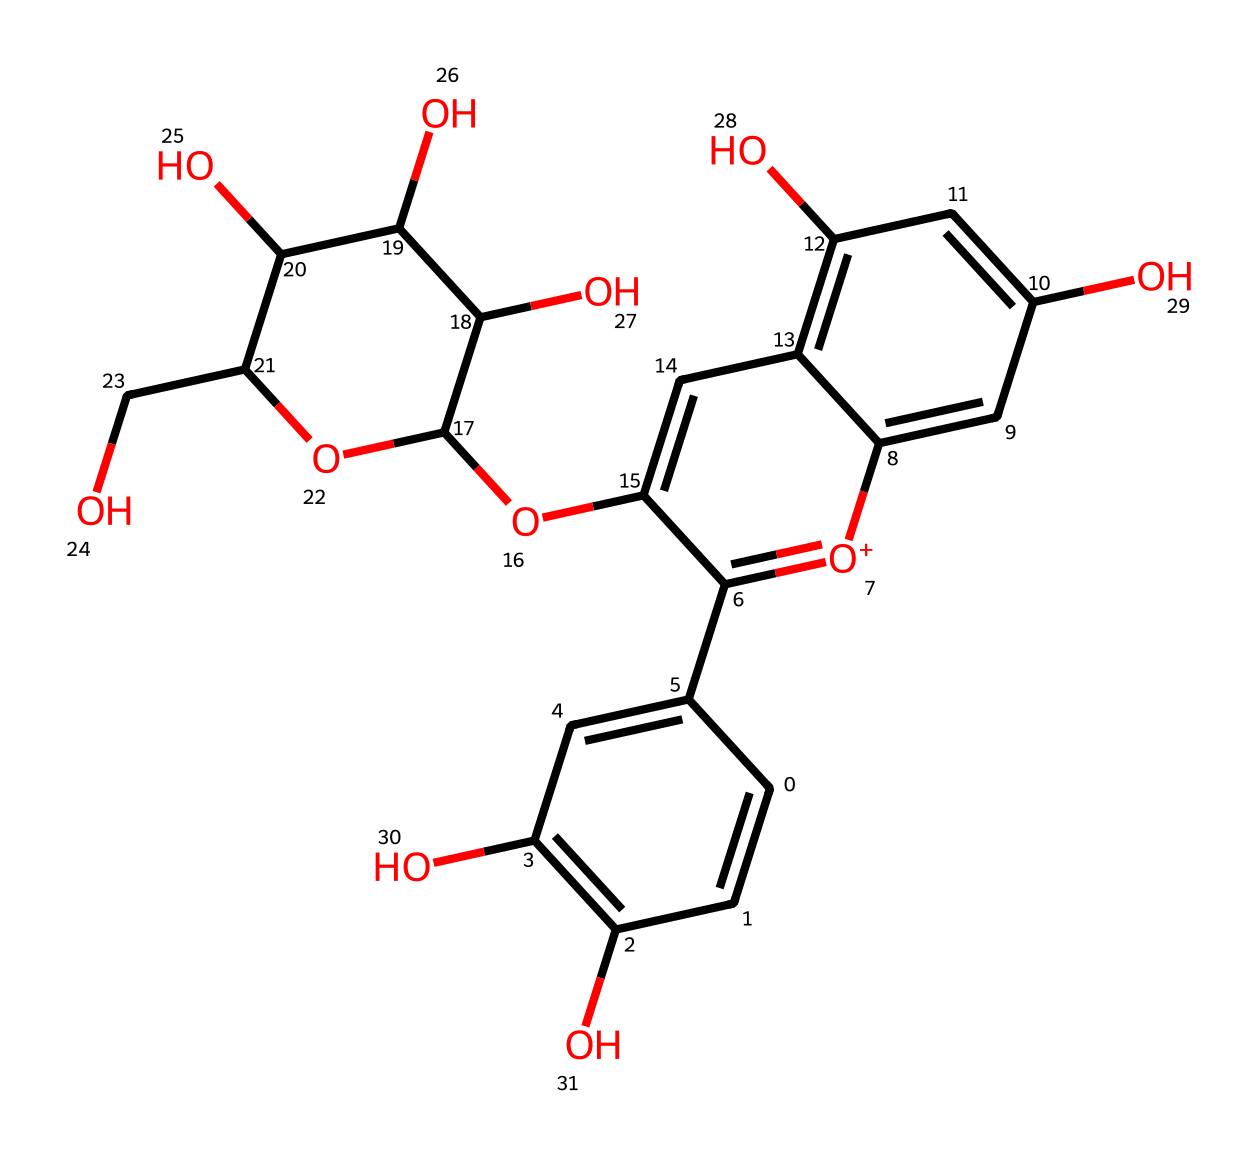What is the total number of carbon atoms in this chemical structure? By examining the SMILES representation, we can count all carbon atoms (C). The SMILES indicates there are 21 carbon atoms present in the molecular structure.
Answer: 21 How many hydroxyl groups are present in this antioxidant structure? Observing the structure, the -OH (hydroxyl) groups can be identified; there are a total of 6 hydroxyl groups in the molecule from the functional groups depicted in the SMILES.
Answer: 6 What type of chemical compound is this antioxidant primarily classified as? The chemical structure shows multiple aromatic rings and hydroxyl groups, indicating that it is a polyphenol compound, which is a common classification for many antioxidants.
Answer: polyphenol What is the molecular weight of this antioxidant? To determine the molecular weight from the SMILES, you would add the weights of all individual atoms (accounting for C, H, O). The total molecular weight calculated for this structure is approximately 444.38 g/mol.
Answer: 444.38 Which part of the structure contributes to its antioxidant properties? The presence of multiple hydroxyl (-OH) groups plays a crucial role in capturing free radicals, making this part responsible for its antioxidant properties.
Answer: hydroxyl groups Is there a presence of any cyclic structures within the chemical? The SMILES notation reveals multiple ring structures, specifically with numbers indicating bonded carbons in cycles, confirming the presence of at least two cyclic components in this antioxidant.
Answer: yes 